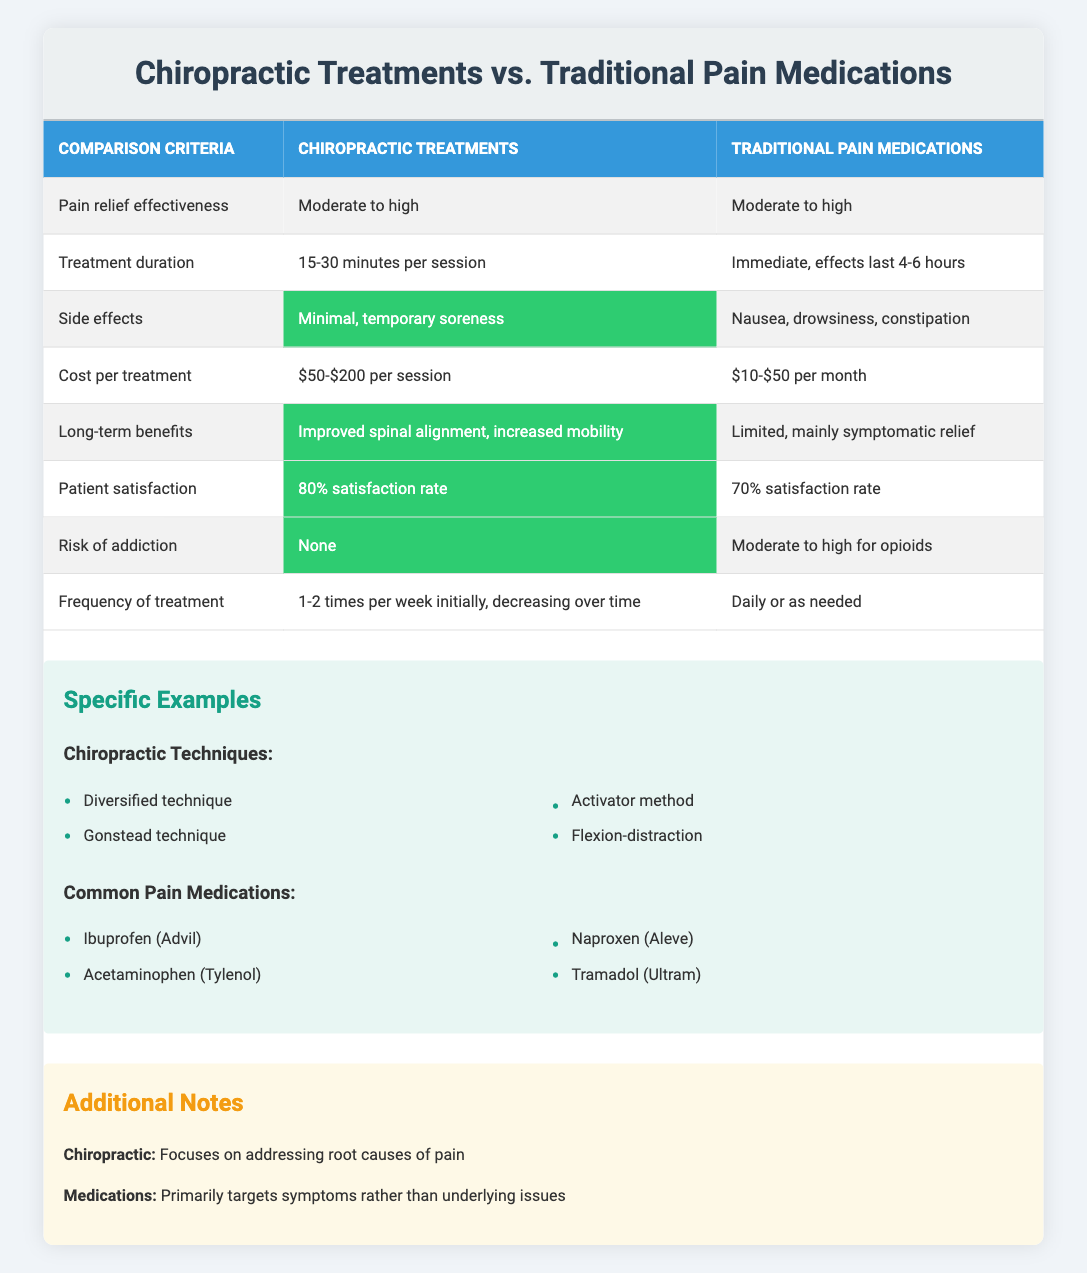What is the pain relief effectiveness of chiropractic treatments? According to the table, chiropractic treatments have a pain relief effectiveness rated as "Moderate to high."
Answer: Moderate to high What are the side effects associated with traditional pain medications? The table lists the side effects of traditional pain medications as "Nausea, drowsiness, constipation."
Answer: Nausea, drowsiness, constipation How do the patient satisfaction rates compare between chiropractic treatments and traditional pain medications? The satisfaction rate for chiropractic treatments is 80%, while for traditional pain medications, it's 70%. This shows that chiropractic treatments have a higher satisfaction rate.
Answer: Chiropractic treatments have a higher satisfaction rate What is the cost per treatment for chiropractic treatments compared to traditional pain medications? The cost per treatment for chiropractic treatments ranges from $50 to $200 per session, while traditional pain medications cost between $10 to $50 per month. Chiropractic treatments are typically more costly.
Answer: Chiropractic treatments are more costly Is there a risk of addiction associated with chiropractic treatments? The table indicates that there is "None" for chiropractic treatments, which means there is no risk of addiction.
Answer: No What is the frequency of treatment for chiropractic therapies compared to traditional pain medications? Chiropractic treatments are typically administered 1-2 times per week initially, decreasing over time. In contrast, traditional pain medications are taken daily or as needed. This indicates a more structured treatment schedule for chiropractic therapies.
Answer: Chiropractic treatments have a more structured frequency What are the long-term benefits of chiropractic treatments? The table states that the long-term benefits of chiropractic treatments include "Improved spinal alignment, increased mobility," which helps address foundational health issues.
Answer: Improved spinal alignment, increased mobility If a patient wants to avoid side effects, which option should they choose? The side effects for chiropractic treatments are described as "Minimal, temporary soreness," whereas traditional pain medications have multiple side effects. Therefore, a patient wanting to avoid side effects should choose chiropractic treatments.
Answer: Chiropractic treatments What is the treatment duration for chiropractic therapies compared to traditional pain medications? Chiropractic treatments last "15-30 minutes per session," while traditional pain medications provide immediate effects lasting "4-6 hours." This indicates that chiropractic sessions are shorter in duration.
Answer: Chiropractic sessions are shorter in duration 